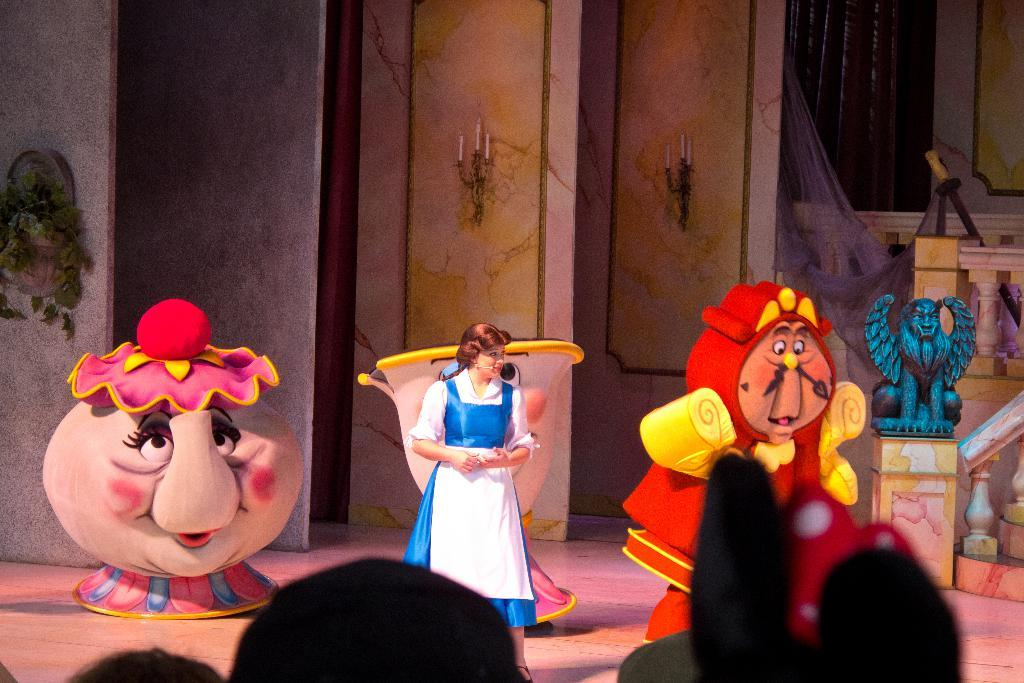Who is the main subject in the image? There is a lady in the image. Where is the lady positioned in the image? The lady is standing in the center of the image. What else can be seen in the center of the image? There are cartoon characters in the center of the image. How many plants are being harvested in the plantation in the image? There is no plantation or plants visible in the image; it features a lady standing in the center with cartoon characters. 